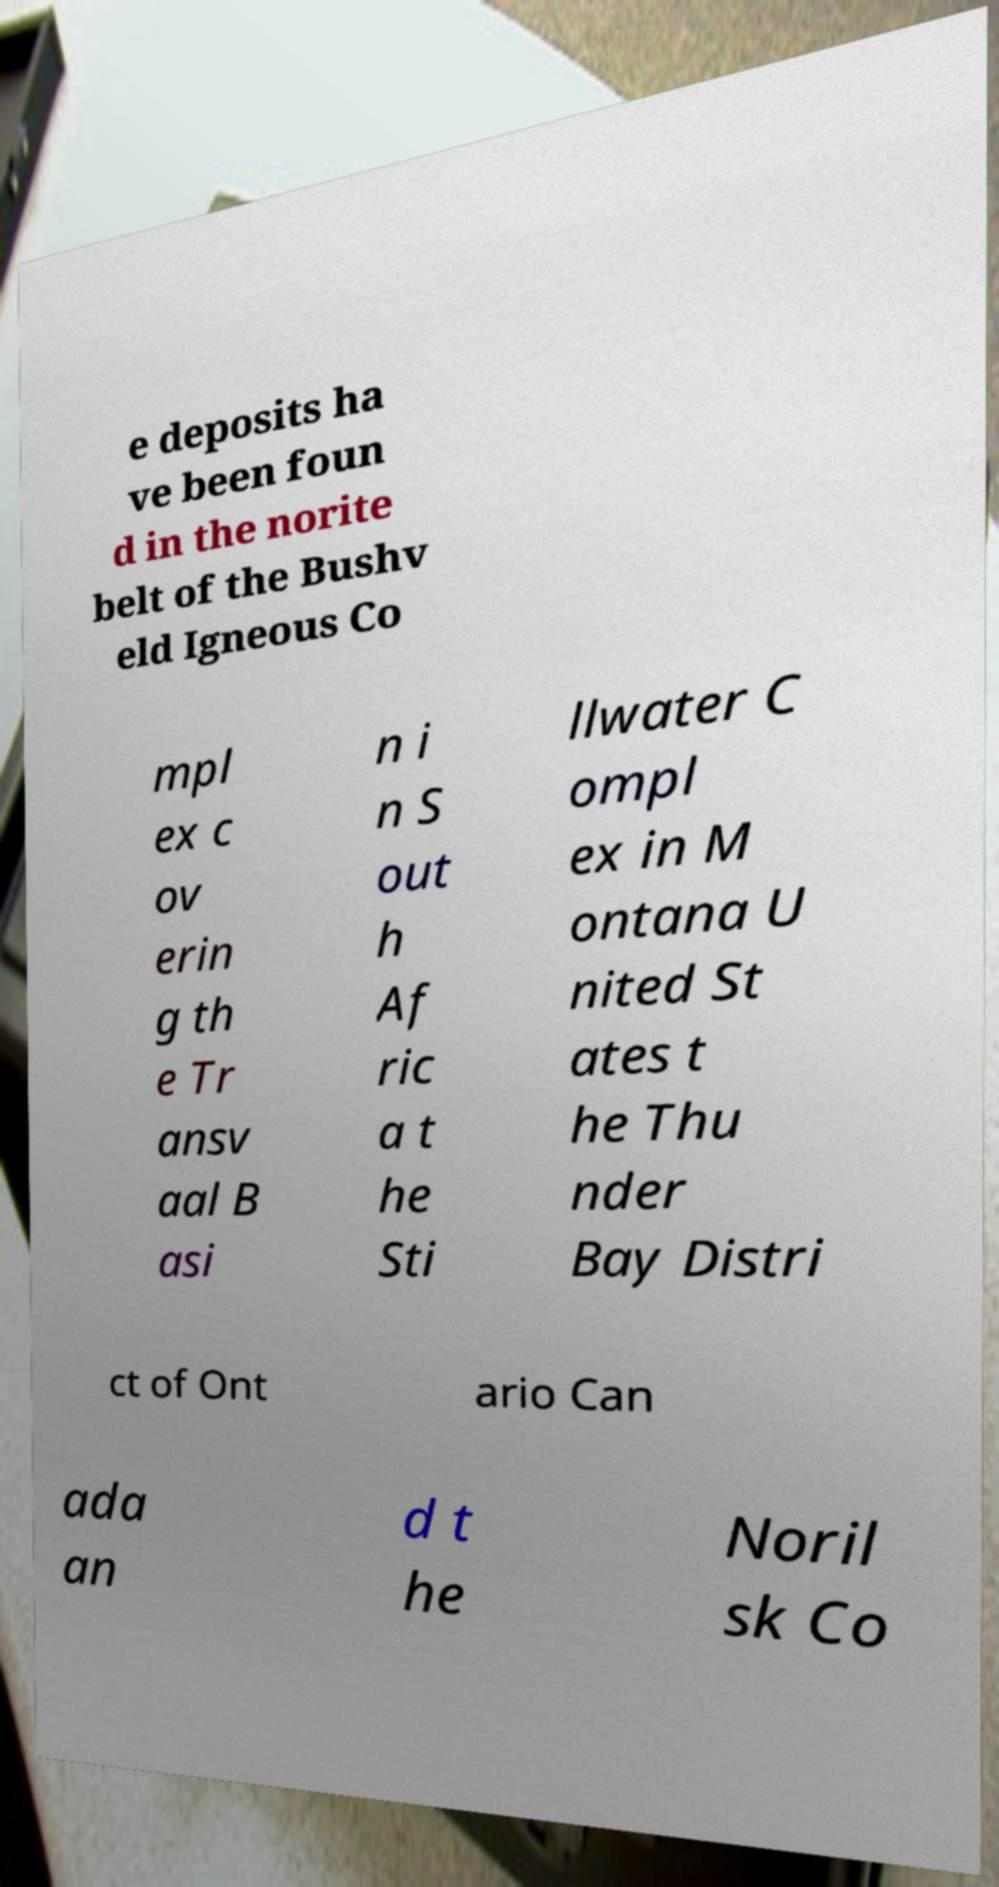Please identify and transcribe the text found in this image. e deposits ha ve been foun d in the norite belt of the Bushv eld Igneous Co mpl ex c ov erin g th e Tr ansv aal B asi n i n S out h Af ric a t he Sti llwater C ompl ex in M ontana U nited St ates t he Thu nder Bay Distri ct of Ont ario Can ada an d t he Noril sk Co 